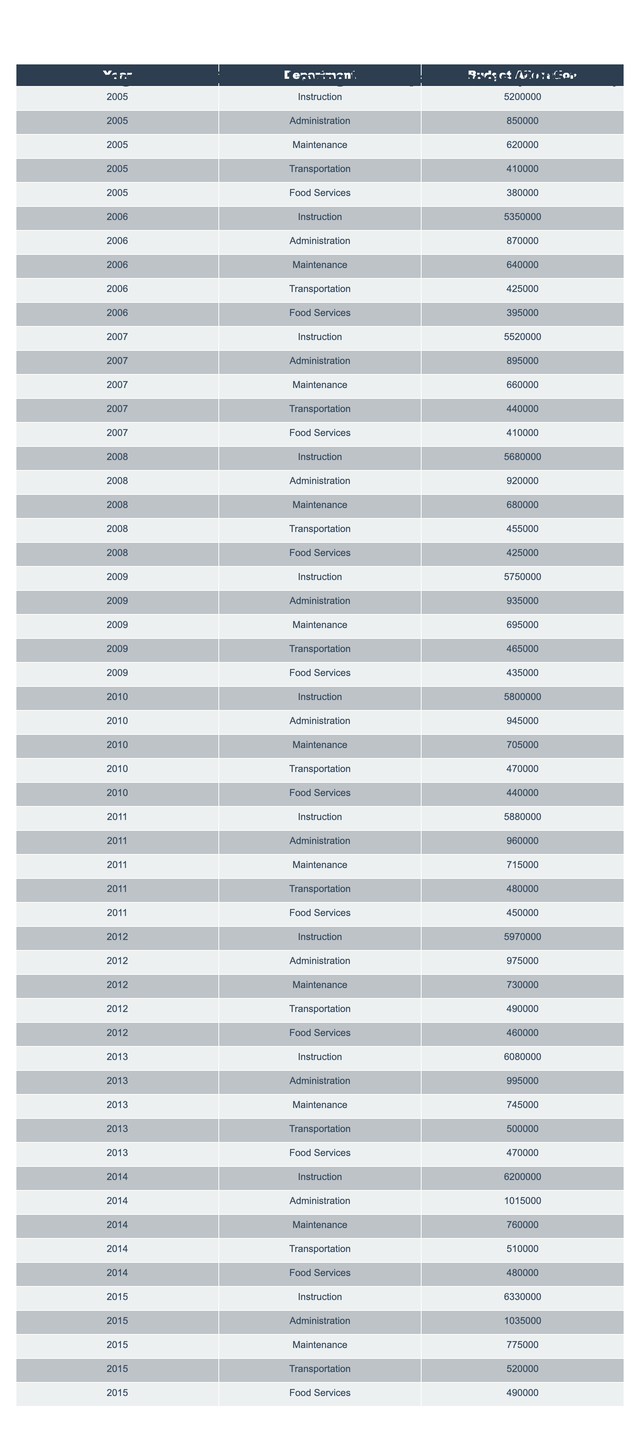What was the total budget allocation for the Food Services department in 2015? In 2015, the budget allocation for Food Services is listed as 490,000.
Answer: 490000 What is the highest budget allocation for the Administration department between 2005 and 2015? The highest budget allocation for the Administration department occurred in 2015 with a budget of 1,035,000.
Answer: 1035000 What was the average budget allocation for the Maintenance department from 2005 to 2015? The budget allocations for Maintenance from 2005 to 2015 are 620,000, 640,000, 660,000, 680,000, 695,000, 705,000, 715,000, 730,000, 745,000, 760,000, 775,000. The sum is 7,455,000, and dividing by 11 years gives an average of 676,818.18.
Answer: 676818.18 Was there an increase in the budget allocation for Transportation from 2005 to 2015? Yes, the budget went from 410,000 in 2005 to 520,000 in 2015, indicating an increase of 110,000.
Answer: Yes What is the total budget allocation for the Instruction department over the ten years? The budget allocations for Instruction are: 5,200,000, 5,350,000, 5,520,000, 5,680,000, 5,750,000, 5,800,000, 5,880,000, 5,970,000, 6,080,000, 6,200,000, 6,330,000. The total is 61,580,000.
Answer: 61580000 In which year did the Food Services budget see its largest increase compared to the previous year? The largest increase occurred from 2012 to 2013, where the allocation increased from 460,000 to 470,000, a difference of 10,000.
Answer: 10,000 What was the average budget allocated to the Administration department from 2005 to 2015? The Administration budget allocations are 850,000, 870,000, 895,000, 920,000, 935,000, 945,000, 960,000, 975,000, 995,000, 1,015,000, 1,035,000. The average is calculated as the sum of these values divided by 11, which equals 949,545.45.
Answer: 949545.45 Did the total budget for the Transportation department remain consistent each year? No, the budget for Transportation varied each year, increasing from 410,000 in 2005 to 520,000 in 2015.
Answer: No Which department had the highest budget allocation in 2014? The Instruction department had the highest allocation in 2014 with a budget of 6,200,000.
Answer: 6200000 What was the percentage increase in the budget allocation for Food Services from 2005 (380,000) to 2015 (490,000)? The increase is calculated as (490,000 - 380,000) / 380,000 * 100%, which gives a percentage increase of approximately 28.95%.
Answer: 28.95% 